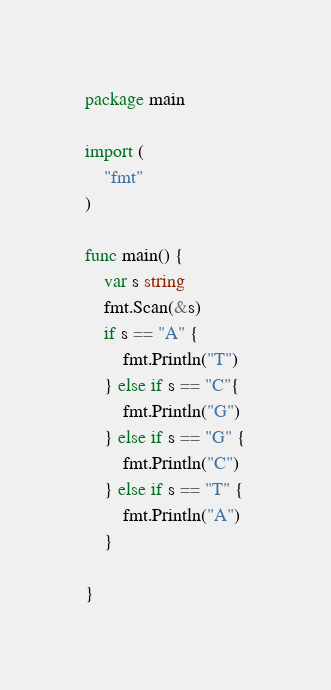Convert code to text. <code><loc_0><loc_0><loc_500><loc_500><_Go_>package main

import (
	"fmt"
)

func main() {
	var s string
	fmt.Scan(&s)
	if s == "A" {
		fmt.Println("T")
	} else if s == "C"{
		fmt.Println("G")
	} else if s == "G" {
		fmt.Println("C")
	} else if s == "T" {
		fmt.Println("A")
	}
	
}
</code> 